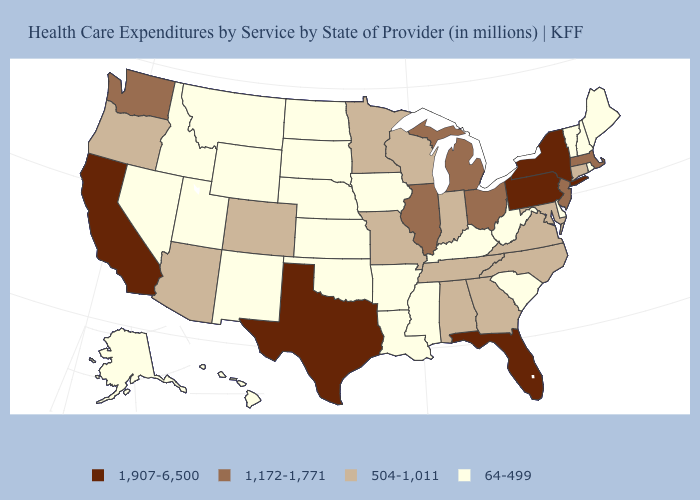Among the states that border Colorado , does Kansas have the lowest value?
Concise answer only. Yes. What is the lowest value in states that border North Carolina?
Concise answer only. 64-499. Name the states that have a value in the range 64-499?
Short answer required. Alaska, Arkansas, Delaware, Hawaii, Idaho, Iowa, Kansas, Kentucky, Louisiana, Maine, Mississippi, Montana, Nebraska, Nevada, New Hampshire, New Mexico, North Dakota, Oklahoma, Rhode Island, South Carolina, South Dakota, Utah, Vermont, West Virginia, Wyoming. Name the states that have a value in the range 504-1,011?
Be succinct. Alabama, Arizona, Colorado, Connecticut, Georgia, Indiana, Maryland, Minnesota, Missouri, North Carolina, Oregon, Tennessee, Virginia, Wisconsin. What is the value of West Virginia?
Answer briefly. 64-499. Among the states that border Florida , which have the highest value?
Be succinct. Alabama, Georgia. Name the states that have a value in the range 1,172-1,771?
Concise answer only. Illinois, Massachusetts, Michigan, New Jersey, Ohio, Washington. Name the states that have a value in the range 504-1,011?
Short answer required. Alabama, Arizona, Colorado, Connecticut, Georgia, Indiana, Maryland, Minnesota, Missouri, North Carolina, Oregon, Tennessee, Virginia, Wisconsin. What is the value of Maryland?
Quick response, please. 504-1,011. Which states hav the highest value in the South?
Be succinct. Florida, Texas. Which states hav the highest value in the West?
Be succinct. California. Which states have the highest value in the USA?
Write a very short answer. California, Florida, New York, Pennsylvania, Texas. What is the lowest value in states that border Montana?
Concise answer only. 64-499. Which states have the highest value in the USA?
Be succinct. California, Florida, New York, Pennsylvania, Texas. What is the lowest value in the Northeast?
Short answer required. 64-499. 